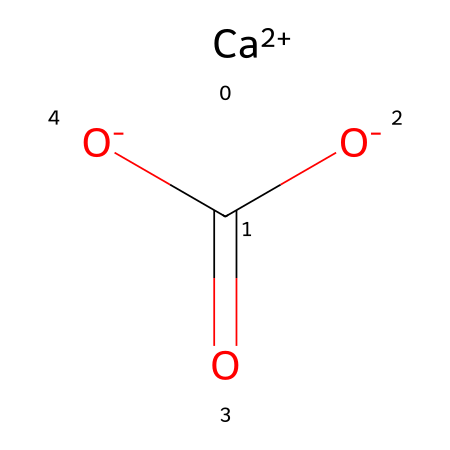What is the total number of different elements present in this molecule? The chemical consists of calcium (Ca), carbon (C), and oxygen (O). Thus, there are three different elements.
Answer: three How many oxygen atoms are present in the structure? The structure shows two oxygen atoms connected to the carbon atom and one oxygen atom connected to the calcium ion, making a total of three oxygen atoms.
Answer: three What is the charge of the calcium ion in this structure? The SMILES notation indicates that the calcium atom is represented as [Ca+2], which specifies that it has a charge of +2.
Answer: +2 Which part of this molecule acts as the cation? The calcium ion ([Ca+2]) acts as the cation in this structure because it carries a positive charge.
Answer: calcium ion What type of bond is likely present between the calcium ion and the carbonate ion? Since calcium is a cation and the carbonate has a negative charge, an ionic bond is formed between them due to electrostatic attraction.
Answer: ionic bond Which functional group is present in the molecular structure of calcium carbonate? The carbonate ion (CO3) contains the functional group, specifically a carbonate group, which is indicated by the arrangement of carbon and oxygen atoms.
Answer: carbonate group 